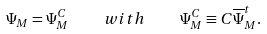Convert formula to latex. <formula><loc_0><loc_0><loc_500><loc_500>\Psi _ { M } = \Psi _ { M } ^ { C } \quad w i t h \quad \Psi _ { M } ^ { C } \equiv C \overline { \Psi } _ { M } ^ { t } .</formula> 